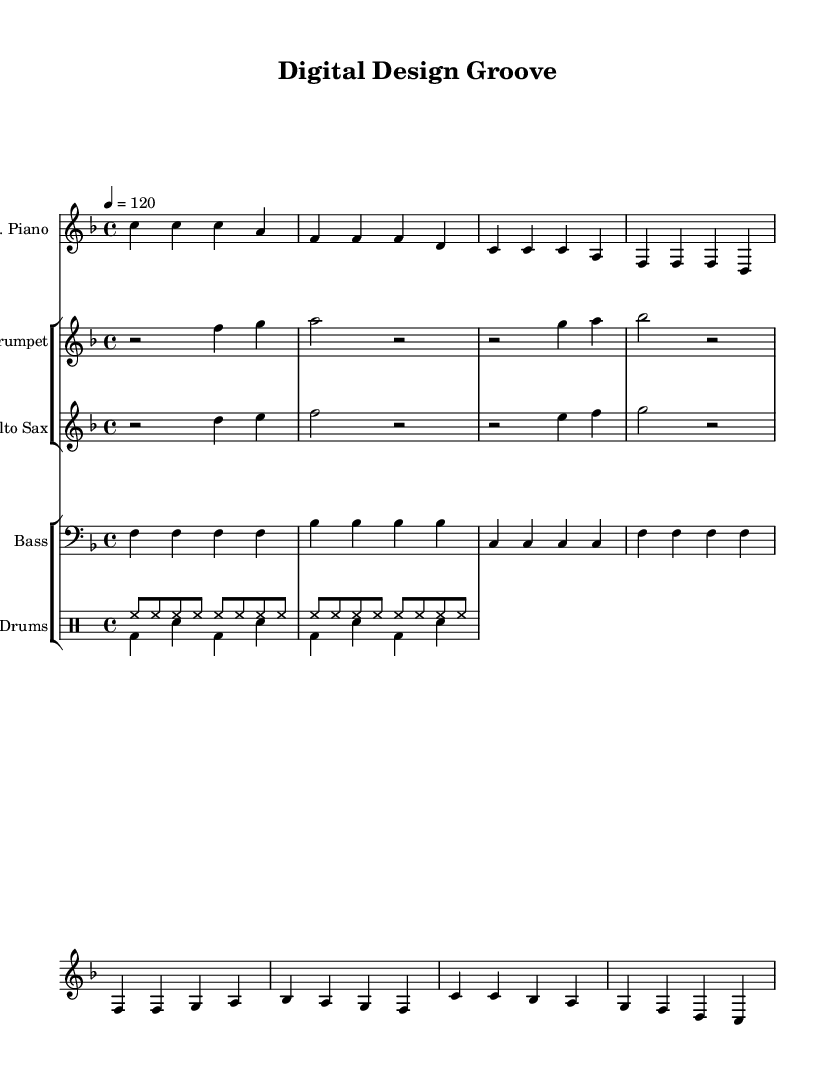What is the key signature of this music? The key signature is F major, which has one flat (B flat) indicated at the beginning of the staff.
Answer: F major What is the time signature of this piece? The time signature is 4/4, which means there are four beats in a measure and a quarter note receives one beat.
Answer: 4/4 What is the tempo marking given in the score? The tempo marking is 120 beats per minute, indicated by the notation "4 = 120" at the beginning of the music.
Answer: 120 How many measures are in the verse section? The verse section consists of four measures as seen in the electric piano part where each group of four notes represents a measure.
Answer: 4 Which instruments are included in this score? The instruments in this score include electric piano, trumpet, alto sax, bass guitar, and drums. These are listed at the beginning of each staff.
Answer: Electric piano, trumpet, alto sax, bass guitar, drums What are the lyrics describing in the chorus? The lyrics in the chorus describe passion and pride in digital design, celebrating the life brought to games and the experiences provided to players.
Answer: Passion and pride in digital design How does the bass line support the groove of the song? The bass line played on the bass guitar provides a rhythmic foundation with steady quarter notes that enhances the groove, supporting the overall funky feel.
Answer: Steady quarter notes 